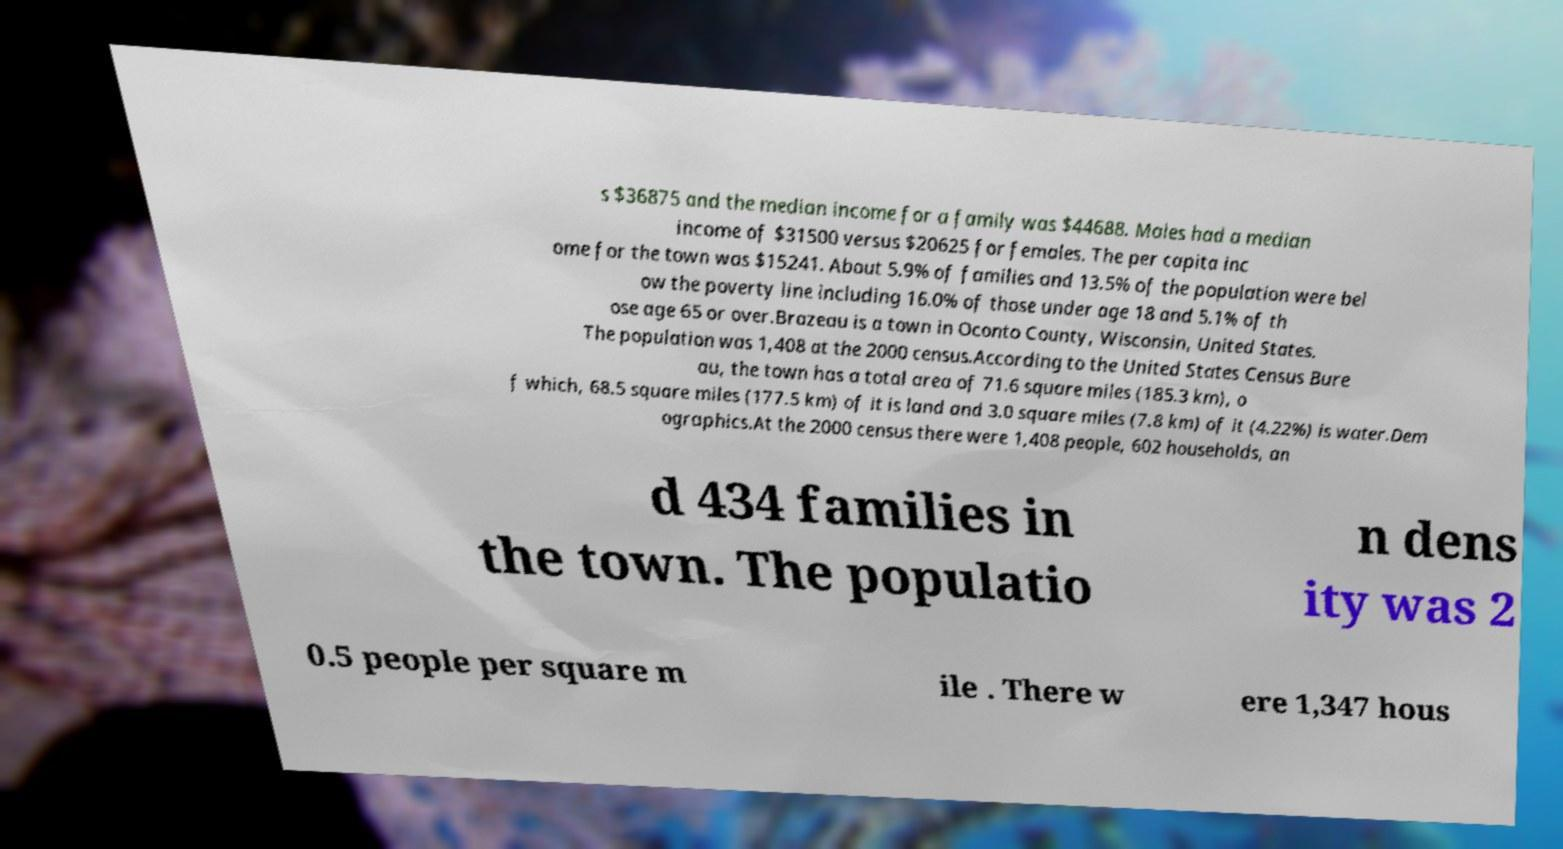Could you extract and type out the text from this image? s $36875 and the median income for a family was $44688. Males had a median income of $31500 versus $20625 for females. The per capita inc ome for the town was $15241. About 5.9% of families and 13.5% of the population were bel ow the poverty line including 16.0% of those under age 18 and 5.1% of th ose age 65 or over.Brazeau is a town in Oconto County, Wisconsin, United States. The population was 1,408 at the 2000 census.According to the United States Census Bure au, the town has a total area of 71.6 square miles (185.3 km), o f which, 68.5 square miles (177.5 km) of it is land and 3.0 square miles (7.8 km) of it (4.22%) is water.Dem ographics.At the 2000 census there were 1,408 people, 602 households, an d 434 families in the town. The populatio n dens ity was 2 0.5 people per square m ile . There w ere 1,347 hous 